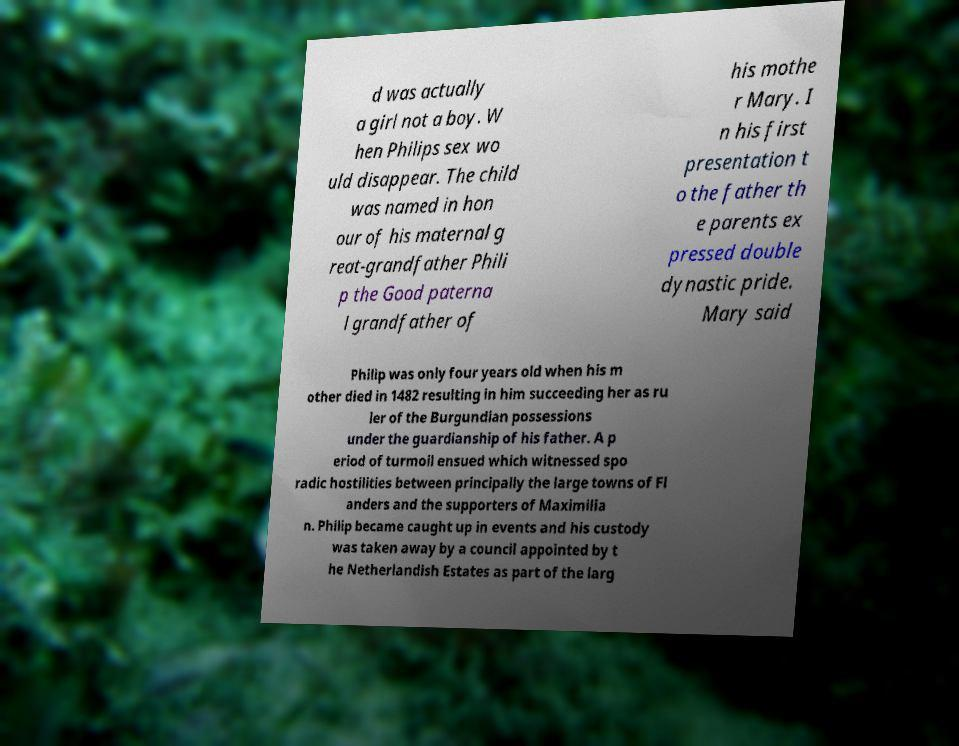For documentation purposes, I need the text within this image transcribed. Could you provide that? d was actually a girl not a boy. W hen Philips sex wo uld disappear. The child was named in hon our of his maternal g reat-grandfather Phili p the Good paterna l grandfather of his mothe r Mary. I n his first presentation t o the father th e parents ex pressed double dynastic pride. Mary said Philip was only four years old when his m other died in 1482 resulting in him succeeding her as ru ler of the Burgundian possessions under the guardianship of his father. A p eriod of turmoil ensued which witnessed spo radic hostilities between principally the large towns of Fl anders and the supporters of Maximilia n. Philip became caught up in events and his custody was taken away by a council appointed by t he Netherlandish Estates as part of the larg 